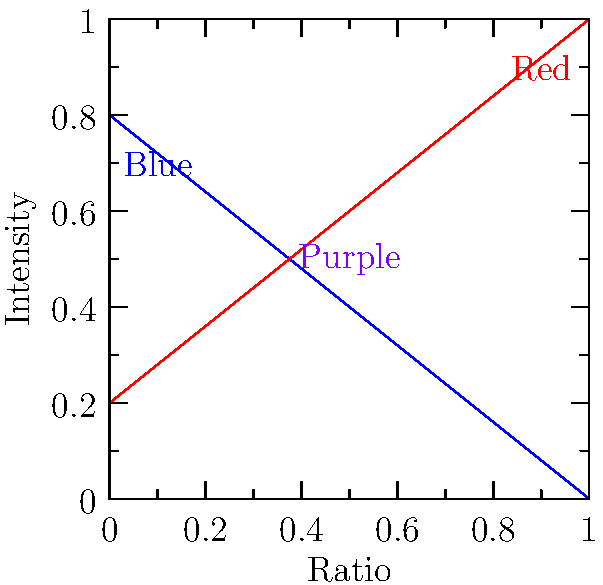As a street artist, you're creating a mural that requires a perfect purple hue. Using the graph showing the intensity of blue and red pigments, at what ratio of blue to red paint will you achieve the most vibrant purple? To find the most vibrant purple, we need to determine where the blue and red pigments have equal intensity. This occurs at the intersection of the two lines in the graph.

Step 1: Identify the equations of the lines
Blue line: $y = 0.8 - 0.8x$
Red line: $y = 0.2 + 0.8x$

Step 2: Find the intersection point by equating the two lines
$0.8 - 0.8x = 0.2 + 0.8x$

Step 3: Solve for x
$0.8 - 0.2 = 0.8x + 0.8x$
$0.6 = 1.6x$
$x = 0.375$

Step 4: Interpret the result
The x-axis represents the ratio of red paint. Therefore, the ratio of blue to red paint is:
Blue : Red = $(1 - 0.375) : 0.375 = 0.625 : 0.375$

Step 5: Simplify the ratio
Divide both numbers by 0.125:
Blue : Red = $5 : 3$

This 5:3 ratio of blue to red paint will produce the most vibrant purple for your mural.
Answer: 5:3 (blue:red) 